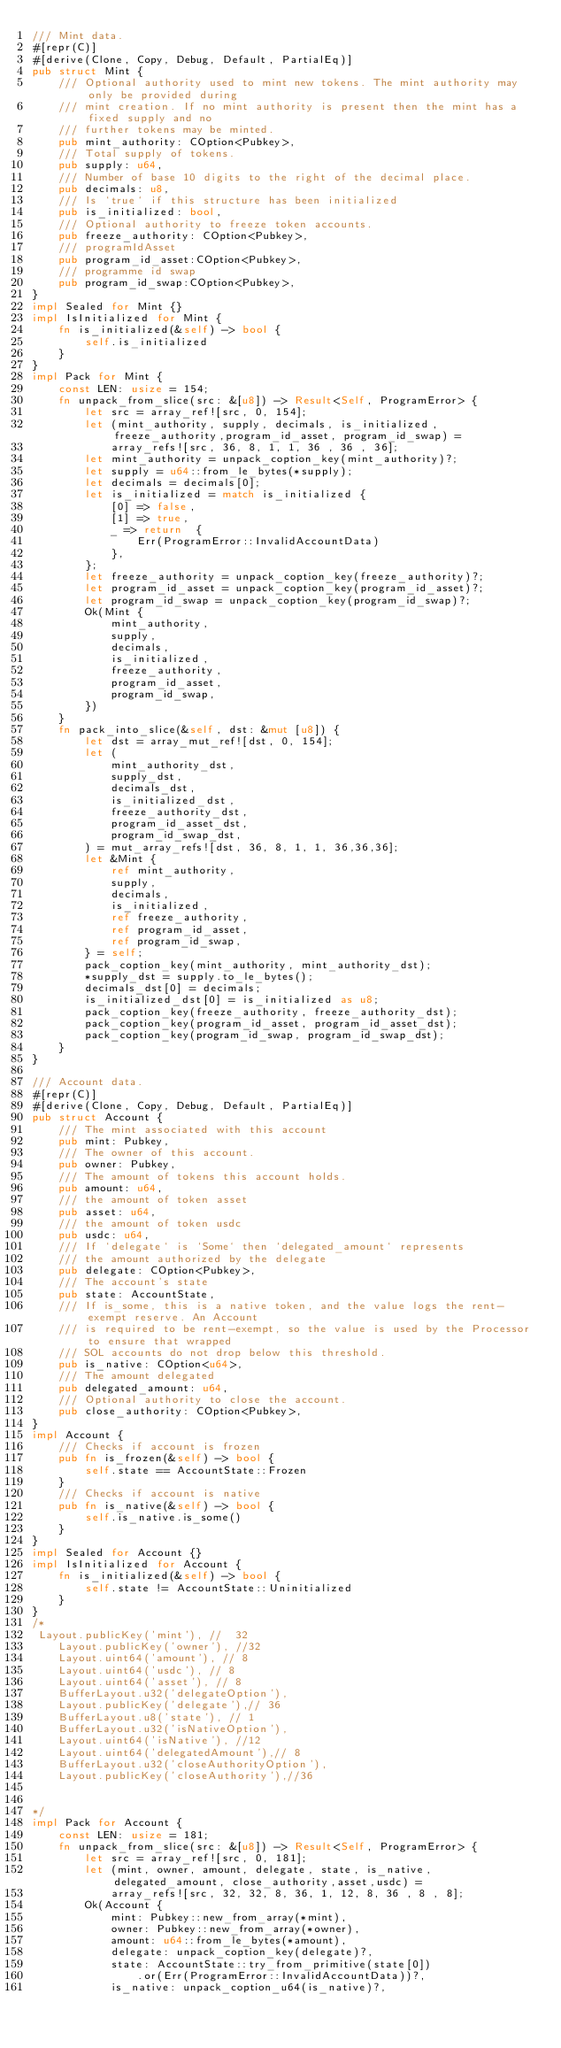Convert code to text. <code><loc_0><loc_0><loc_500><loc_500><_Rust_>/// Mint data.
#[repr(C)]
#[derive(Clone, Copy, Debug, Default, PartialEq)]
pub struct Mint {
    /// Optional authority used to mint new tokens. The mint authority may only be provided during
    /// mint creation. If no mint authority is present then the mint has a fixed supply and no
    /// further tokens may be minted.
    pub mint_authority: COption<Pubkey>,
    /// Total supply of tokens.
    pub supply: u64,
    /// Number of base 10 digits to the right of the decimal place.
    pub decimals: u8,
    /// Is `true` if this structure has been initialized
    pub is_initialized: bool,
    /// Optional authority to freeze token accounts.
    pub freeze_authority: COption<Pubkey>,
    /// programIdAsset
    pub program_id_asset:COption<Pubkey>,
    /// programme id swap
    pub program_id_swap:COption<Pubkey>,
}
impl Sealed for Mint {}
impl IsInitialized for Mint {
    fn is_initialized(&self) -> bool {
        self.is_initialized
    }
}
impl Pack for Mint {
    const LEN: usize = 154;
    fn unpack_from_slice(src: &[u8]) -> Result<Self, ProgramError> {
        let src = array_ref![src, 0, 154];
        let (mint_authority, supply, decimals, is_initialized, freeze_authority,program_id_asset, program_id_swap) =
            array_refs![src, 36, 8, 1, 1, 36 , 36 , 36];
        let mint_authority = unpack_coption_key(mint_authority)?;
        let supply = u64::from_le_bytes(*supply);
        let decimals = decimals[0];
        let is_initialized = match is_initialized {
            [0] => false,
            [1] => true,
            _ => return  { 
                Err(ProgramError::InvalidAccountData)
            },
        };
        let freeze_authority = unpack_coption_key(freeze_authority)?;
        let program_id_asset = unpack_coption_key(program_id_asset)?;
        let program_id_swap = unpack_coption_key(program_id_swap)?;
        Ok(Mint {
            mint_authority,
            supply,
            decimals,
            is_initialized,
            freeze_authority,
            program_id_asset,
            program_id_swap,
        })
    }
    fn pack_into_slice(&self, dst: &mut [u8]) {
        let dst = array_mut_ref![dst, 0, 154];
        let (
            mint_authority_dst,
            supply_dst,
            decimals_dst,
            is_initialized_dst,
            freeze_authority_dst,
            program_id_asset_dst,
            program_id_swap_dst,
        ) = mut_array_refs![dst, 36, 8, 1, 1, 36,36,36];
        let &Mint {
            ref mint_authority,
            supply,
            decimals,
            is_initialized,
            ref freeze_authority,
            ref program_id_asset,
            ref program_id_swap,
        } = self;
        pack_coption_key(mint_authority, mint_authority_dst);
        *supply_dst = supply.to_le_bytes();
        decimals_dst[0] = decimals;
        is_initialized_dst[0] = is_initialized as u8;
        pack_coption_key(freeze_authority, freeze_authority_dst);
        pack_coption_key(program_id_asset, program_id_asset_dst);
        pack_coption_key(program_id_swap, program_id_swap_dst);
    }
}

/// Account data.
#[repr(C)]
#[derive(Clone, Copy, Debug, Default, PartialEq)]
pub struct Account {
    /// The mint associated with this account
    pub mint: Pubkey,
    /// The owner of this account.
    pub owner: Pubkey,
    /// The amount of tokens this account holds.
    pub amount: u64,
    /// the amount of token asset 
    pub asset: u64,
    /// the amount of token usdc
    pub usdc: u64,
    /// If `delegate` is `Some` then `delegated_amount` represents
    /// the amount authorized by the delegate
    pub delegate: COption<Pubkey>,
    /// The account's state
    pub state: AccountState,
    /// If is_some, this is a native token, and the value logs the rent-exempt reserve. An Account
    /// is required to be rent-exempt, so the value is used by the Processor to ensure that wrapped
    /// SOL accounts do not drop below this threshold.
    pub is_native: COption<u64>,
    /// The amount delegated
    pub delegated_amount: u64,
    /// Optional authority to close the account.
    pub close_authority: COption<Pubkey>,
}
impl Account {
    /// Checks if account is frozen
    pub fn is_frozen(&self) -> bool {
        self.state == AccountState::Frozen
    }
    /// Checks if account is native
    pub fn is_native(&self) -> bool {
        self.is_native.is_some()
    }
}
impl Sealed for Account {}
impl IsInitialized for Account {
    fn is_initialized(&self) -> bool {
        self.state != AccountState::Uninitialized
    }
}
/*
 Layout.publicKey('mint'), //  32
    Layout.publicKey('owner'), //32
    Layout.uint64('amount'), // 8
    Layout.uint64('usdc'), // 8
    Layout.uint64('asset'), // 8
    BufferLayout.u32('delegateOption'), 
    Layout.publicKey('delegate'),// 36
    BufferLayout.u8('state'), // 1
    BufferLayout.u32('isNativeOption'), 
    Layout.uint64('isNative'), //12
    Layout.uint64('delegatedAmount'),// 8
    BufferLayout.u32('closeAuthorityOption'),
    Layout.publicKey('closeAuthority'),//36


*/
impl Pack for Account {
    const LEN: usize = 181;
    fn unpack_from_slice(src: &[u8]) -> Result<Self, ProgramError> {
        let src = array_ref![src, 0, 181];
        let (mint, owner, amount, delegate, state, is_native, delegated_amount, close_authority,asset,usdc) =
            array_refs![src, 32, 32, 8, 36, 1, 12, 8, 36 , 8 , 8];
        Ok(Account {
            mint: Pubkey::new_from_array(*mint),
            owner: Pubkey::new_from_array(*owner),
            amount: u64::from_le_bytes(*amount),
            delegate: unpack_coption_key(delegate)?,
            state: AccountState::try_from_primitive(state[0])
                .or(Err(ProgramError::InvalidAccountData))?,
            is_native: unpack_coption_u64(is_native)?,</code> 